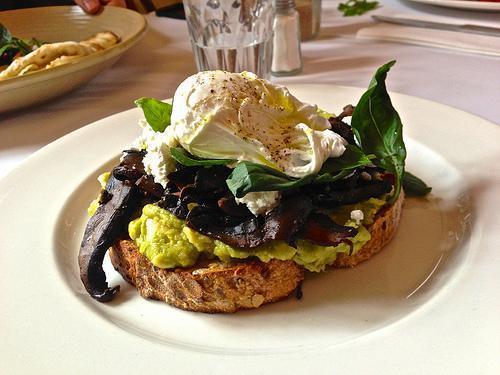How many plates?
Give a very brief answer. 1. 